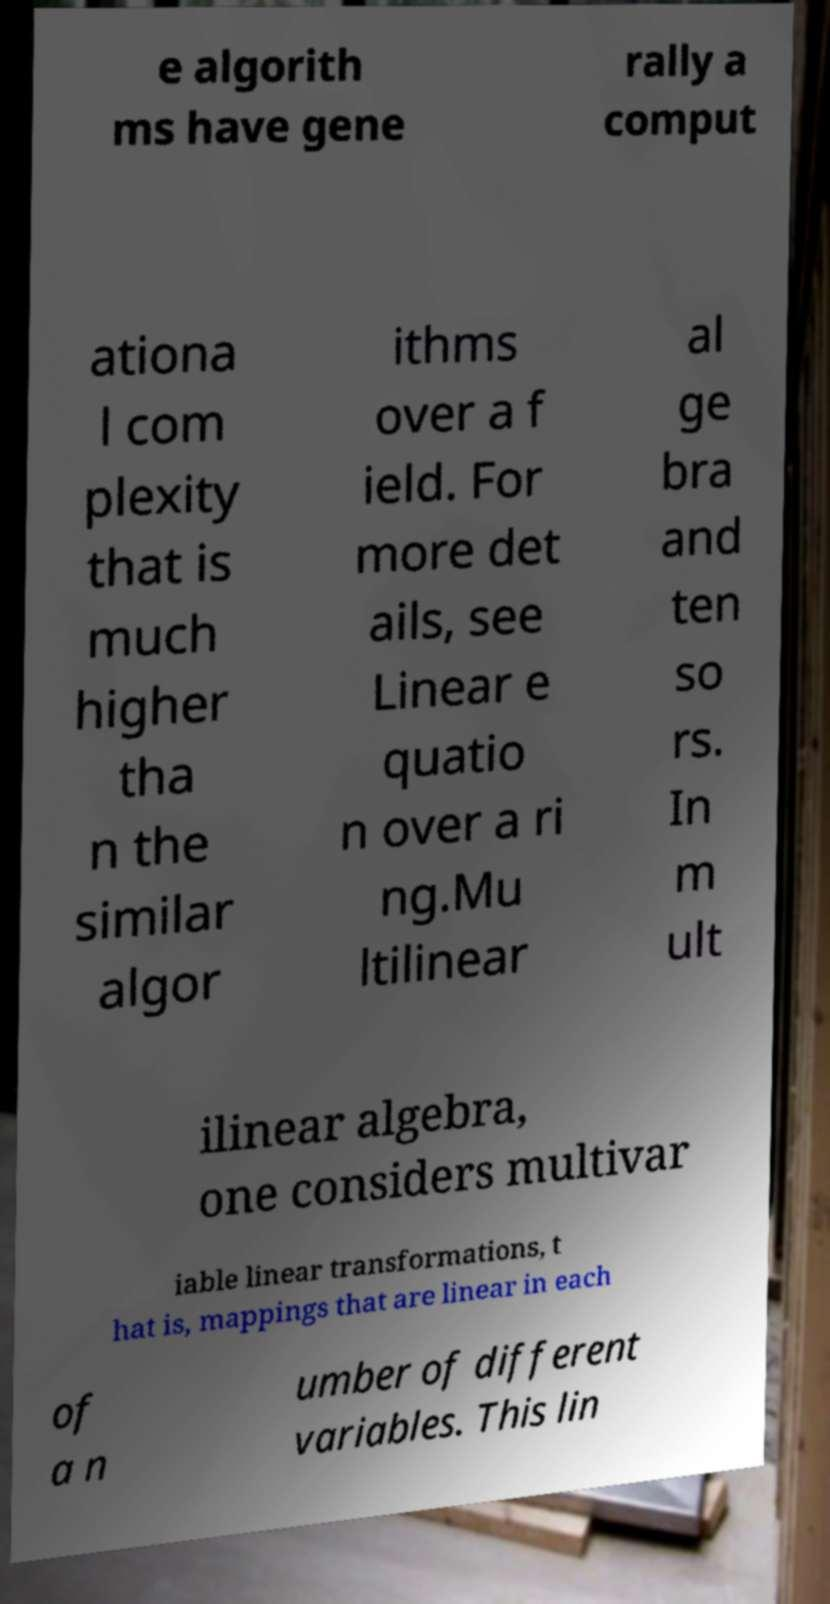There's text embedded in this image that I need extracted. Can you transcribe it verbatim? e algorith ms have gene rally a comput ationa l com plexity that is much higher tha n the similar algor ithms over a f ield. For more det ails, see Linear e quatio n over a ri ng.Mu ltilinear al ge bra and ten so rs. In m ult ilinear algebra, one considers multivar iable linear transformations, t hat is, mappings that are linear in each of a n umber of different variables. This lin 